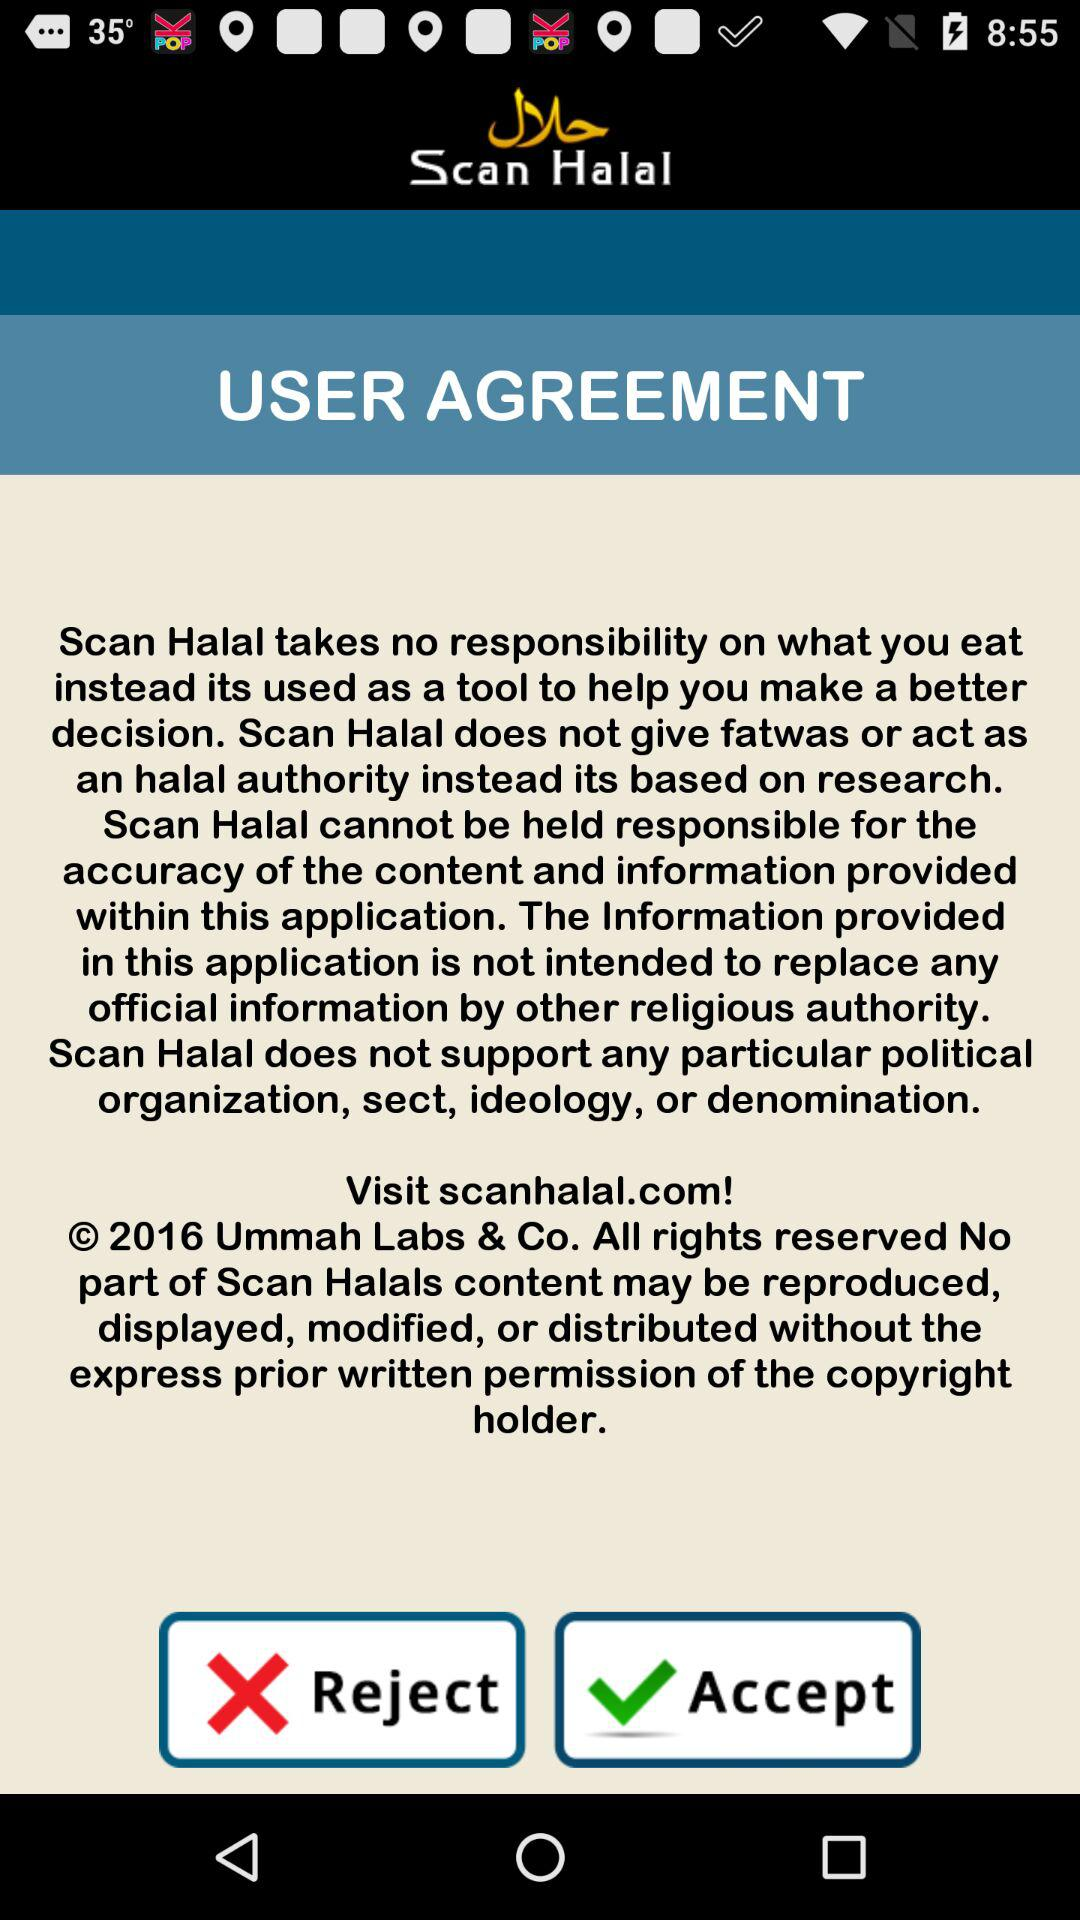What is the name of application? The name of the application is "Scan Halal". 